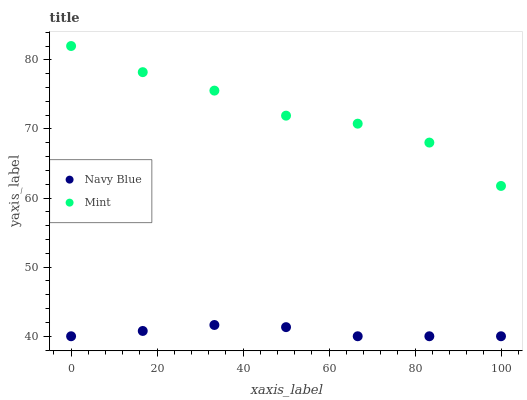Does Navy Blue have the minimum area under the curve?
Answer yes or no. Yes. Does Mint have the maximum area under the curve?
Answer yes or no. Yes. Does Mint have the minimum area under the curve?
Answer yes or no. No. Is Navy Blue the smoothest?
Answer yes or no. Yes. Is Mint the roughest?
Answer yes or no. Yes. Is Mint the smoothest?
Answer yes or no. No. Does Navy Blue have the lowest value?
Answer yes or no. Yes. Does Mint have the lowest value?
Answer yes or no. No. Does Mint have the highest value?
Answer yes or no. Yes. Is Navy Blue less than Mint?
Answer yes or no. Yes. Is Mint greater than Navy Blue?
Answer yes or no. Yes. Does Navy Blue intersect Mint?
Answer yes or no. No. 